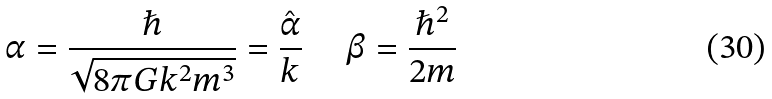<formula> <loc_0><loc_0><loc_500><loc_500>\alpha = \frac { \hslash } { \sqrt { 8 \pi G k ^ { 2 } m ^ { 3 } } } = \frac { \hat { \alpha } } { k } \text { \quad } \beta = \frac { \hslash ^ { 2 } } { 2 m }</formula> 